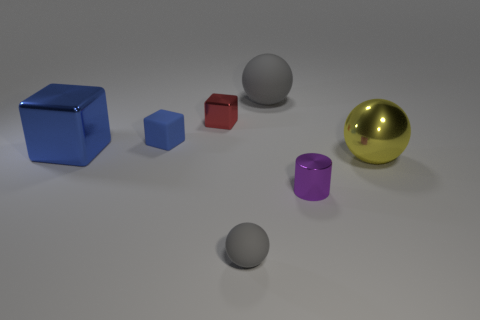What time of day does the lighting in the scene suggest? The even and diffused lighting in the scene does not strongly suggest any particular time of day. It appears to be neutral, studio lighting, commonly used in product visualization to minimize shadows and evenly reveal the shape and texture of objects. 